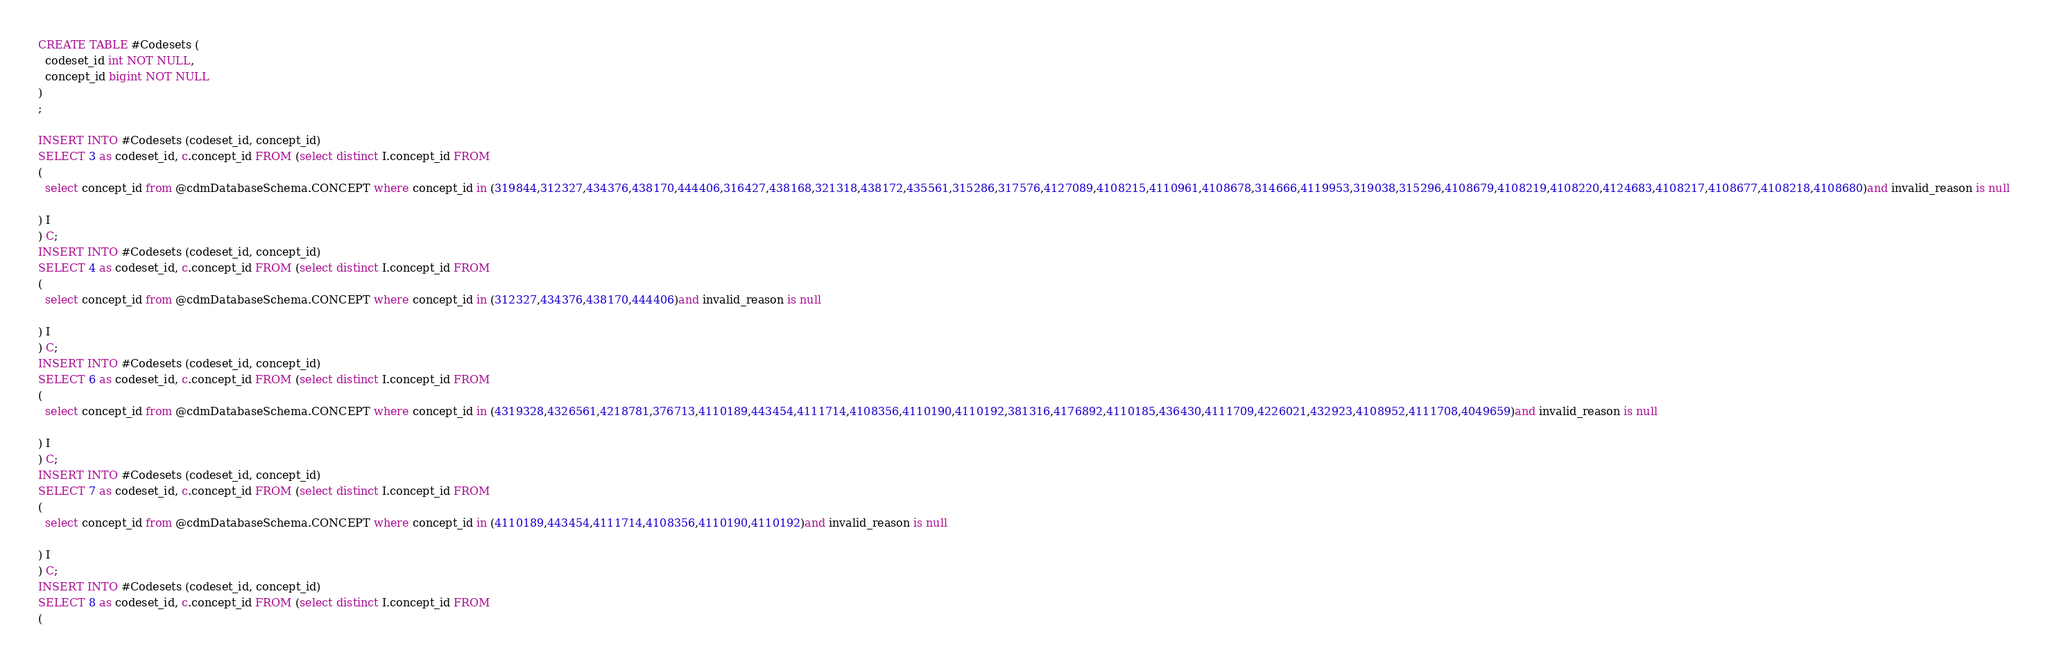Convert code to text. <code><loc_0><loc_0><loc_500><loc_500><_SQL_>CREATE TABLE #Codesets (
  codeset_id int NOT NULL,
  concept_id bigint NOT NULL
)
;

INSERT INTO #Codesets (codeset_id, concept_id)
SELECT 3 as codeset_id, c.concept_id FROM (select distinct I.concept_id FROM
( 
  select concept_id from @cdmDatabaseSchema.CONCEPT where concept_id in (319844,312327,434376,438170,444406,316427,438168,321318,438172,435561,315286,317576,4127089,4108215,4110961,4108678,314666,4119953,319038,315296,4108679,4108219,4108220,4124683,4108217,4108677,4108218,4108680)and invalid_reason is null

) I
) C;
INSERT INTO #Codesets (codeset_id, concept_id)
SELECT 4 as codeset_id, c.concept_id FROM (select distinct I.concept_id FROM
( 
  select concept_id from @cdmDatabaseSchema.CONCEPT where concept_id in (312327,434376,438170,444406)and invalid_reason is null

) I
) C;
INSERT INTO #Codesets (codeset_id, concept_id)
SELECT 6 as codeset_id, c.concept_id FROM (select distinct I.concept_id FROM
( 
  select concept_id from @cdmDatabaseSchema.CONCEPT where concept_id in (4319328,4326561,4218781,376713,4110189,443454,4111714,4108356,4110190,4110192,381316,4176892,4110185,436430,4111709,4226021,432923,4108952,4111708,4049659)and invalid_reason is null

) I
) C;
INSERT INTO #Codesets (codeset_id, concept_id)
SELECT 7 as codeset_id, c.concept_id FROM (select distinct I.concept_id FROM
( 
  select concept_id from @cdmDatabaseSchema.CONCEPT where concept_id in (4110189,443454,4111714,4108356,4110190,4110192)and invalid_reason is null

) I
) C;
INSERT INTO #Codesets (codeset_id, concept_id)
SELECT 8 as codeset_id, c.concept_id FROM (select distinct I.concept_id FROM
( </code> 